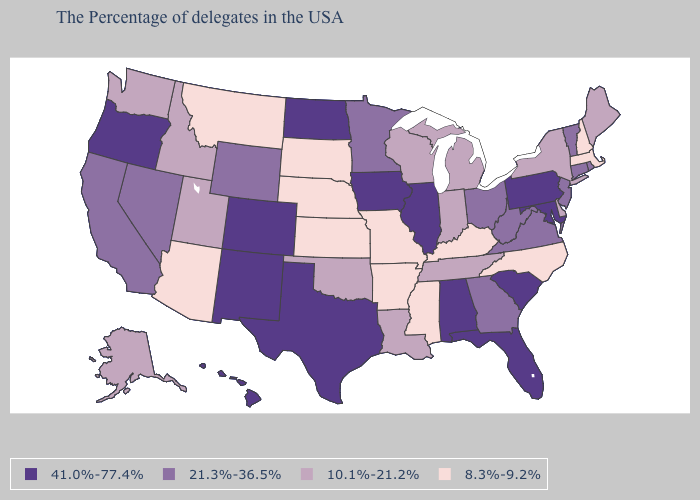Name the states that have a value in the range 21.3%-36.5%?
Quick response, please. Rhode Island, Vermont, Connecticut, New Jersey, Virginia, West Virginia, Ohio, Georgia, Minnesota, Wyoming, Nevada, California. Name the states that have a value in the range 41.0%-77.4%?
Answer briefly. Maryland, Pennsylvania, South Carolina, Florida, Alabama, Illinois, Iowa, Texas, North Dakota, Colorado, New Mexico, Oregon, Hawaii. Does Idaho have a lower value than Pennsylvania?
Concise answer only. Yes. What is the value of Massachusetts?
Concise answer only. 8.3%-9.2%. Does Wyoming have the highest value in the USA?
Short answer required. No. Does Montana have the lowest value in the West?
Answer briefly. Yes. Does the map have missing data?
Keep it brief. No. Name the states that have a value in the range 10.1%-21.2%?
Be succinct. Maine, New York, Delaware, Michigan, Indiana, Tennessee, Wisconsin, Louisiana, Oklahoma, Utah, Idaho, Washington, Alaska. What is the value of Rhode Island?
Short answer required. 21.3%-36.5%. Which states hav the highest value in the West?
Give a very brief answer. Colorado, New Mexico, Oregon, Hawaii. Does North Dakota have the highest value in the USA?
Short answer required. Yes. Which states hav the highest value in the Northeast?
Give a very brief answer. Pennsylvania. What is the value of Oklahoma?
Keep it brief. 10.1%-21.2%. Name the states that have a value in the range 21.3%-36.5%?
Be succinct. Rhode Island, Vermont, Connecticut, New Jersey, Virginia, West Virginia, Ohio, Georgia, Minnesota, Wyoming, Nevada, California. Which states have the lowest value in the USA?
Concise answer only. Massachusetts, New Hampshire, North Carolina, Kentucky, Mississippi, Missouri, Arkansas, Kansas, Nebraska, South Dakota, Montana, Arizona. 